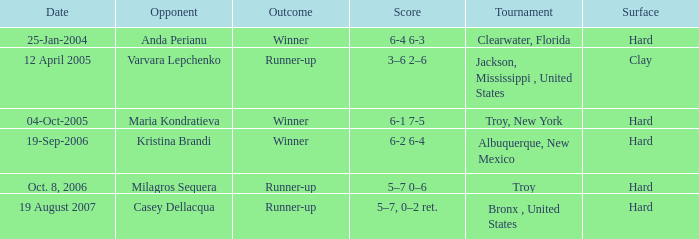What is the final score of the tournament played in Clearwater, Florida? 6-4 6-3. 